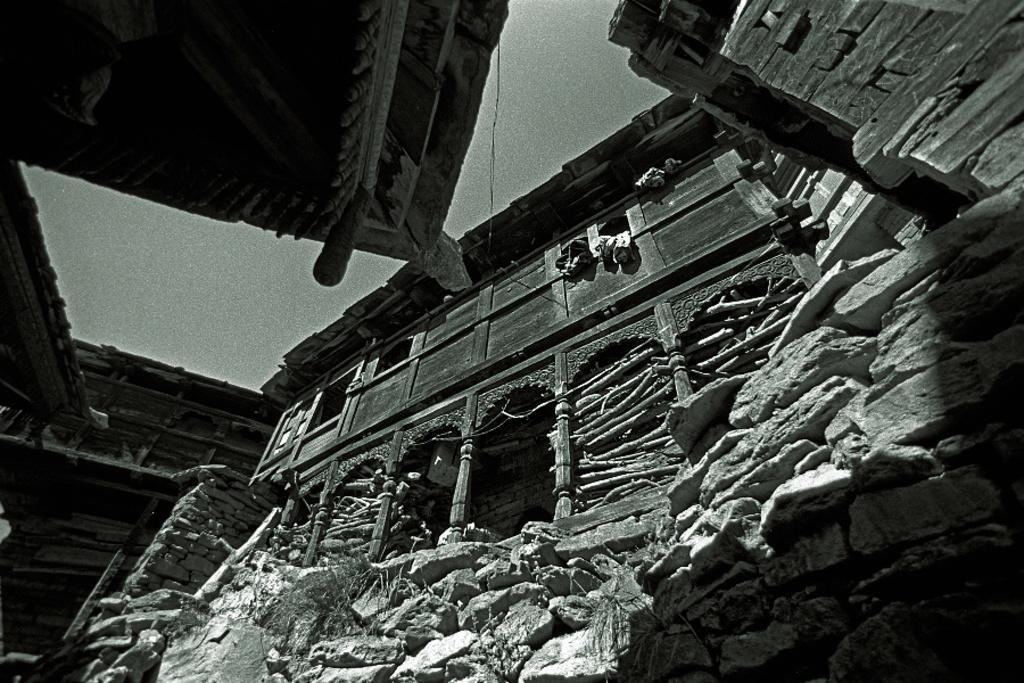What type of structures are visible in the image? There are buildings in the image. What can be seen on the right side of the image? There are stones on the right side of the image. What is the color scheme of the image? The image is in black and white. What type of quill is being used by the committee in the image? There is no committee or quill present in the image. What songs can be heard in the background of the image? There is no audio or background music in the image. 